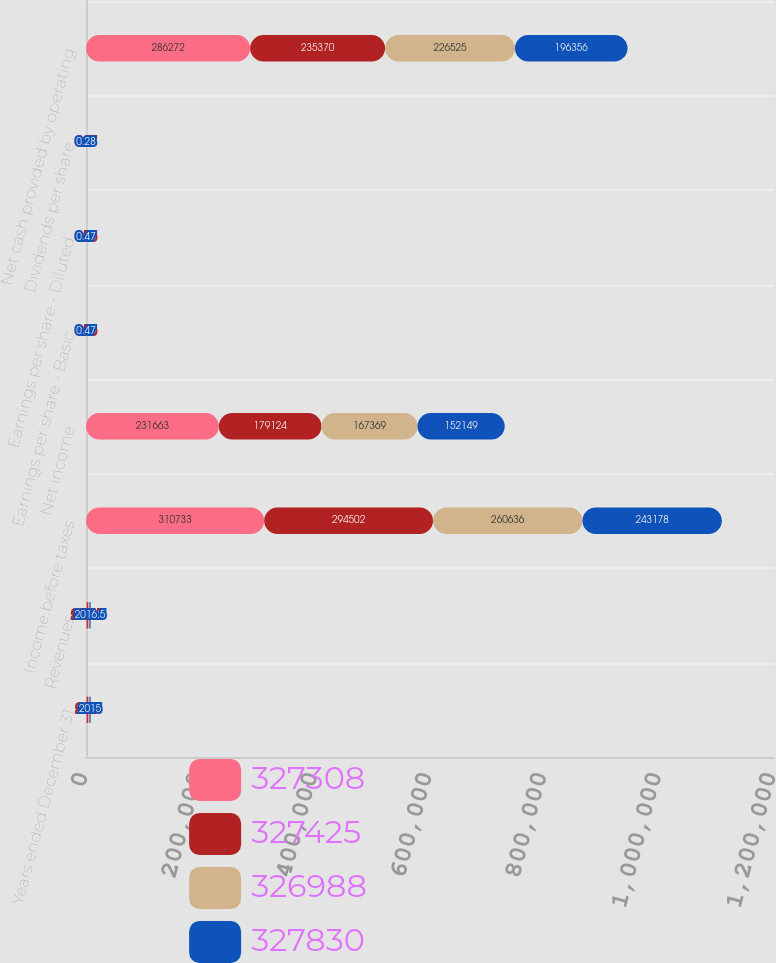Convert chart to OTSL. <chart><loc_0><loc_0><loc_500><loc_500><stacked_bar_chart><ecel><fcel>Years ended December 31<fcel>Revenues<fcel>Income before taxes<fcel>Net income<fcel>Earnings per share - Basic<fcel>Earnings per share - Diluted<fcel>Dividends per share<fcel>Net cash provided by operating<nl><fcel>327308<fcel>2018<fcel>2016.5<fcel>310733<fcel>231663<fcel>0.71<fcel>0.71<fcel>0.47<fcel>286272<nl><fcel>327425<fcel>2017<fcel>2016.5<fcel>294502<fcel>179124<fcel>0.55<fcel>0.55<fcel>0.37<fcel>235370<nl><fcel>326988<fcel>2016<fcel>2016.5<fcel>260636<fcel>167369<fcel>0.51<fcel>0.51<fcel>0.33<fcel>226525<nl><fcel>327830<fcel>2015<fcel>2016.5<fcel>243178<fcel>152149<fcel>0.47<fcel>0.47<fcel>0.28<fcel>196356<nl></chart> 